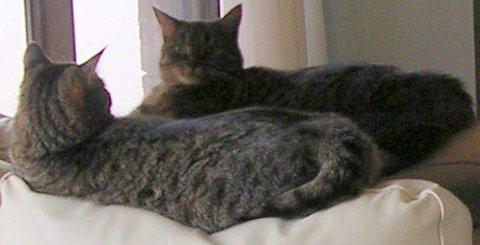What is the cat looking at?
Concise answer only. Mirror. Is this a long haired cat?
Quick response, please. No. What is the cat laying on?
Short answer required. Couch. 